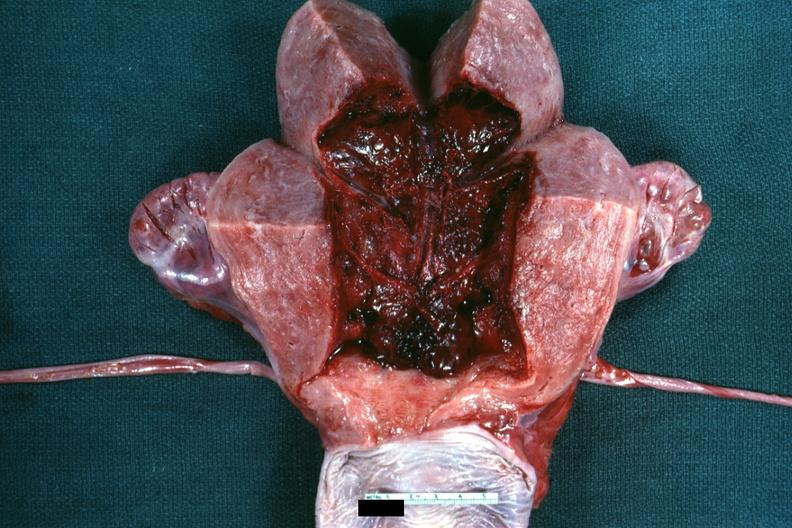what does this image show?
Answer the question using a single word or phrase. 18 hours after cesarean section 